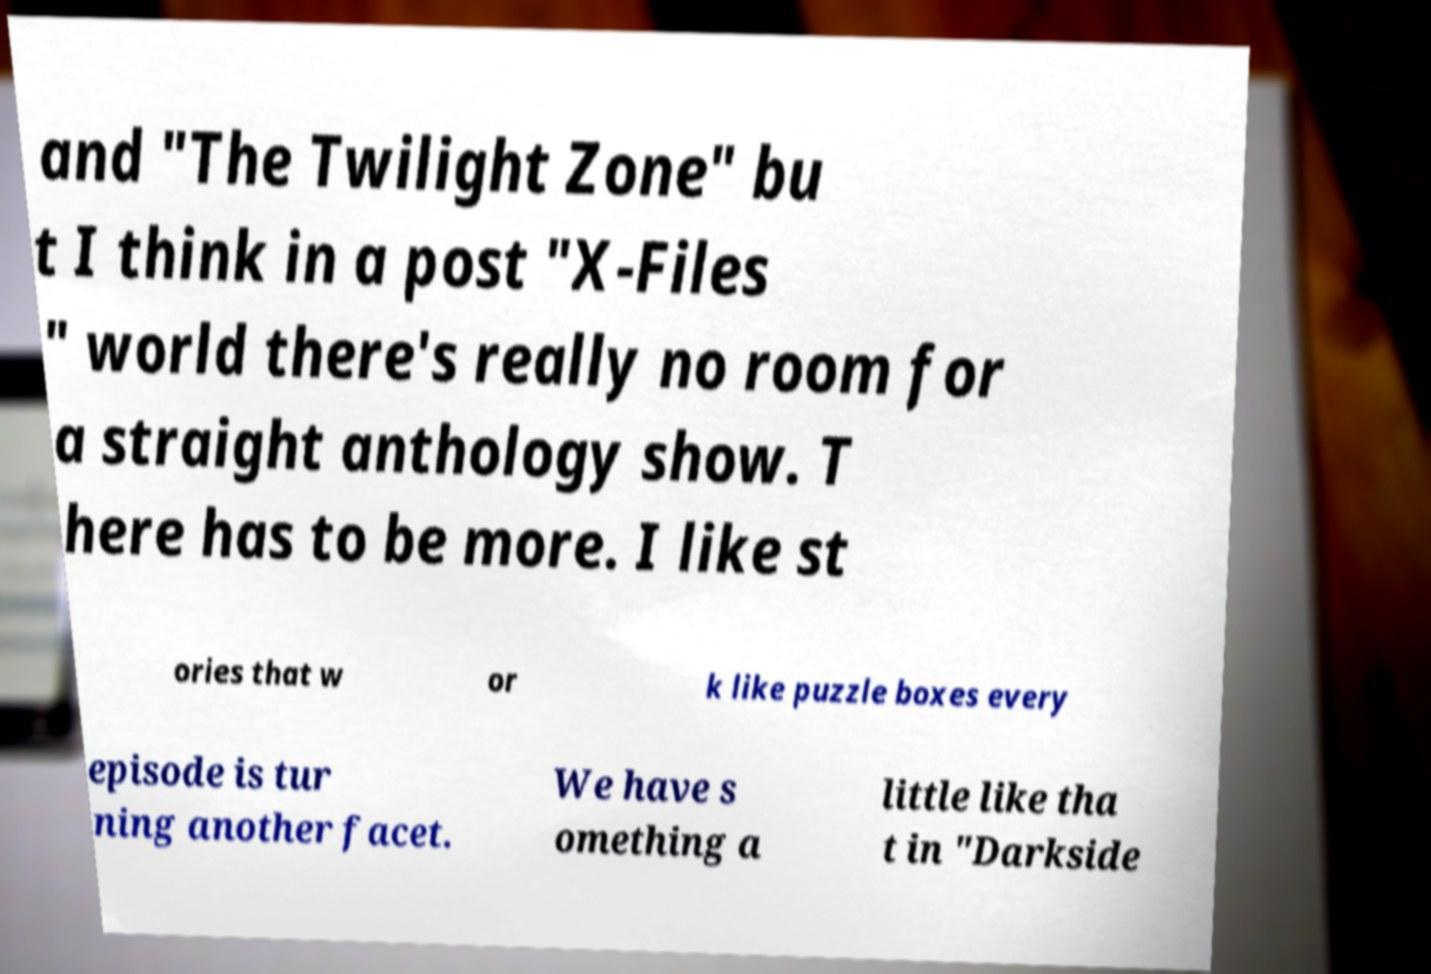I need the written content from this picture converted into text. Can you do that? and "The Twilight Zone" bu t I think in a post "X-Files " world there's really no room for a straight anthology show. T here has to be more. I like st ories that w or k like puzzle boxes every episode is tur ning another facet. We have s omething a little like tha t in "Darkside 